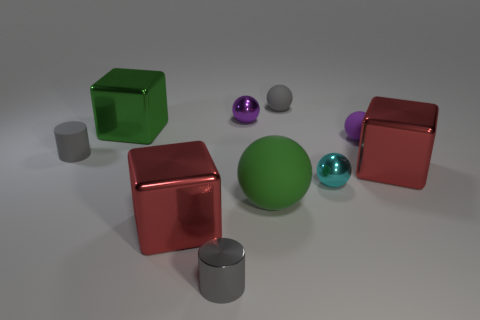Subtract all tiny shiny balls. How many balls are left? 3 Subtract 1 cylinders. How many cylinders are left? 1 Subtract all red cubes. How many cubes are left? 1 Subtract all blue blocks. How many purple spheres are left? 2 Subtract 2 red cubes. How many objects are left? 8 Subtract all cylinders. How many objects are left? 8 Subtract all brown blocks. Subtract all green balls. How many blocks are left? 3 Subtract all big yellow rubber blocks. Subtract all tiny rubber objects. How many objects are left? 7 Add 4 small gray balls. How many small gray balls are left? 5 Add 2 large red blocks. How many large red blocks exist? 4 